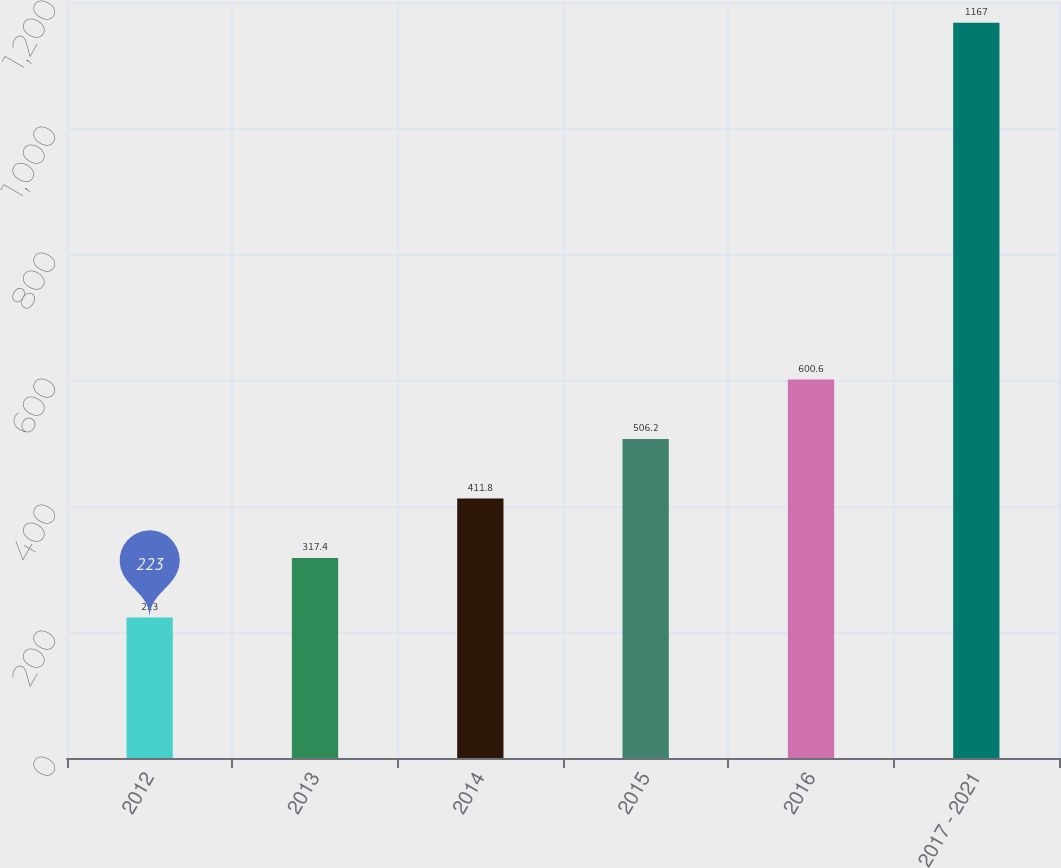Convert chart. <chart><loc_0><loc_0><loc_500><loc_500><bar_chart><fcel>2012<fcel>2013<fcel>2014<fcel>2015<fcel>2016<fcel>2017 - 2021<nl><fcel>223<fcel>317.4<fcel>411.8<fcel>506.2<fcel>600.6<fcel>1167<nl></chart> 